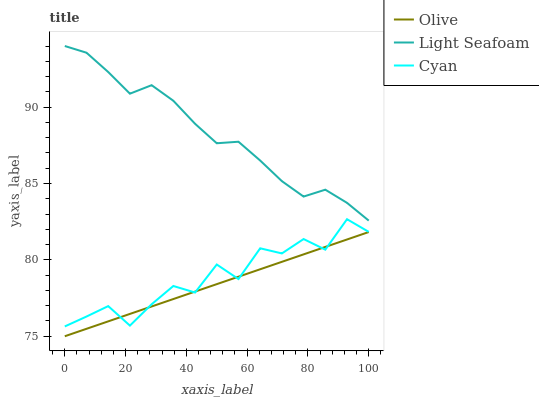Does Olive have the minimum area under the curve?
Answer yes or no. Yes. Does Light Seafoam have the maximum area under the curve?
Answer yes or no. Yes. Does Cyan have the minimum area under the curve?
Answer yes or no. No. Does Cyan have the maximum area under the curve?
Answer yes or no. No. Is Olive the smoothest?
Answer yes or no. Yes. Is Cyan the roughest?
Answer yes or no. Yes. Is Light Seafoam the smoothest?
Answer yes or no. No. Is Light Seafoam the roughest?
Answer yes or no. No. Does Cyan have the lowest value?
Answer yes or no. No. Does Light Seafoam have the highest value?
Answer yes or no. Yes. Does Cyan have the highest value?
Answer yes or no. No. Is Cyan less than Light Seafoam?
Answer yes or no. Yes. Is Light Seafoam greater than Olive?
Answer yes or no. Yes. Does Cyan intersect Olive?
Answer yes or no. Yes. Is Cyan less than Olive?
Answer yes or no. No. Is Cyan greater than Olive?
Answer yes or no. No. Does Cyan intersect Light Seafoam?
Answer yes or no. No. 